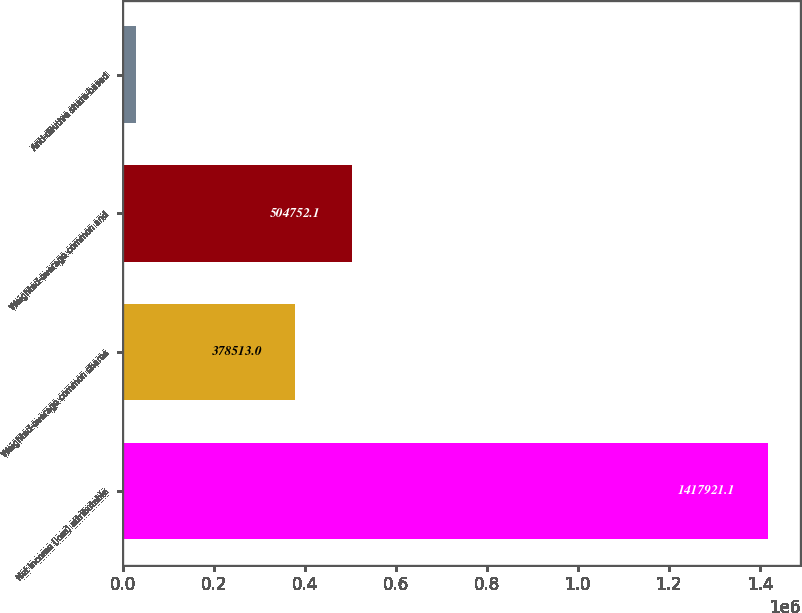Convert chart. <chart><loc_0><loc_0><loc_500><loc_500><bar_chart><fcel>Net income (loss) attributable<fcel>Weighted-average common shares<fcel>Weighted-average common and<fcel>Anti-dilutive share-based<nl><fcel>1.41792e+06<fcel>378513<fcel>504752<fcel>29291<nl></chart> 